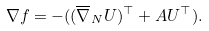<formula> <loc_0><loc_0><loc_500><loc_500>\nabla f = - ( ( \overline { \nabla } _ { N } U ) ^ { \top } + A U ^ { \top } ) .</formula> 